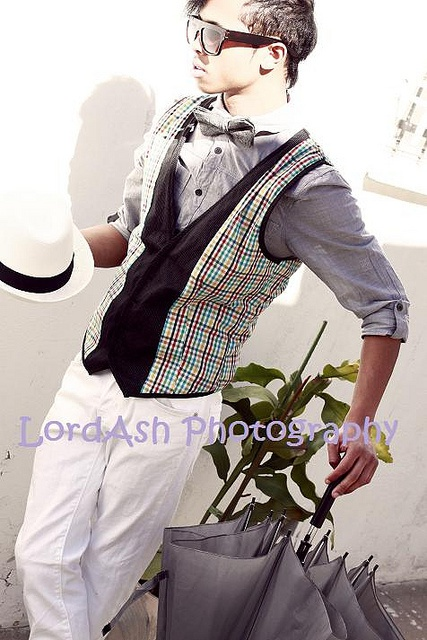Describe the objects in this image and their specific colors. I can see people in white, lightgray, black, darkgray, and gray tones, umbrella in white, gray, and black tones, and tie in white, lightgray, gray, darkgray, and black tones in this image. 